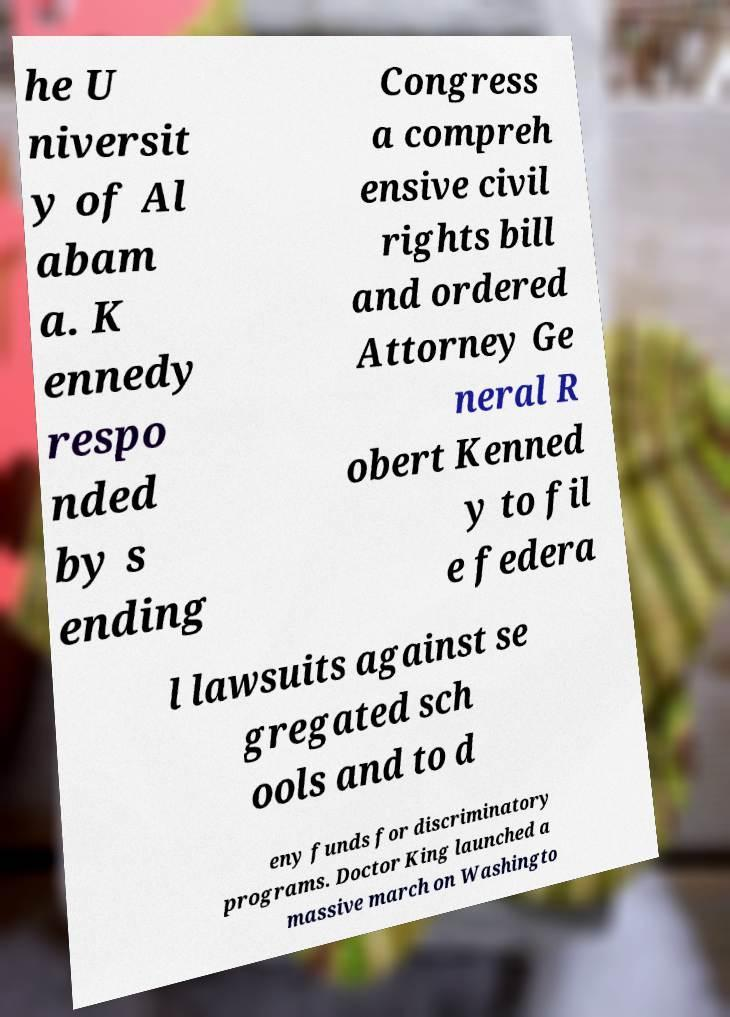What messages or text are displayed in this image? I need them in a readable, typed format. he U niversit y of Al abam a. K ennedy respo nded by s ending Congress a compreh ensive civil rights bill and ordered Attorney Ge neral R obert Kenned y to fil e federa l lawsuits against se gregated sch ools and to d eny funds for discriminatory programs. Doctor King launched a massive march on Washingto 